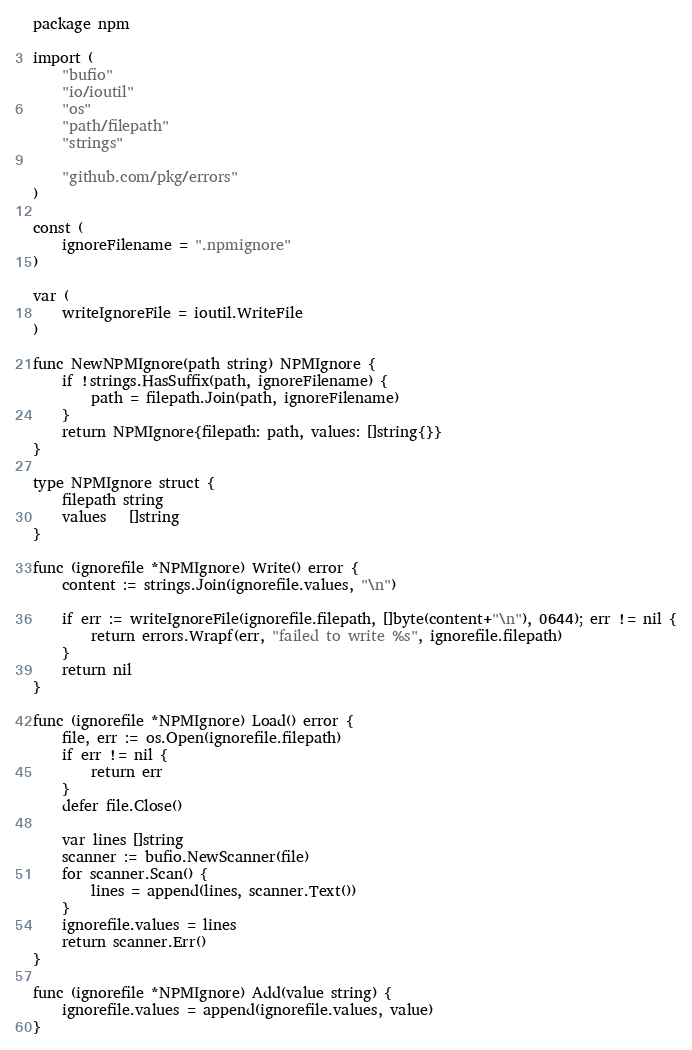Convert code to text. <code><loc_0><loc_0><loc_500><loc_500><_Go_>package npm

import (
	"bufio"
	"io/ioutil"
	"os"
	"path/filepath"
	"strings"

	"github.com/pkg/errors"
)

const (
	ignoreFilename = ".npmignore"
)

var (
	writeIgnoreFile = ioutil.WriteFile
)

func NewNPMIgnore(path string) NPMIgnore {
	if !strings.HasSuffix(path, ignoreFilename) {
		path = filepath.Join(path, ignoreFilename)
	}
	return NPMIgnore{filepath: path, values: []string{}}
}

type NPMIgnore struct {
	filepath string
	values   []string
}

func (ignorefile *NPMIgnore) Write() error {
	content := strings.Join(ignorefile.values, "\n")

	if err := writeIgnoreFile(ignorefile.filepath, []byte(content+"\n"), 0644); err != nil {
		return errors.Wrapf(err, "failed to write %s", ignorefile.filepath)
	}
	return nil
}

func (ignorefile *NPMIgnore) Load() error {
	file, err := os.Open(ignorefile.filepath)
	if err != nil {
		return err
	}
	defer file.Close()

	var lines []string
	scanner := bufio.NewScanner(file)
	for scanner.Scan() {
		lines = append(lines, scanner.Text())
	}
	ignorefile.values = lines
	return scanner.Err()
}

func (ignorefile *NPMIgnore) Add(value string) {
	ignorefile.values = append(ignorefile.values, value)
}
</code> 